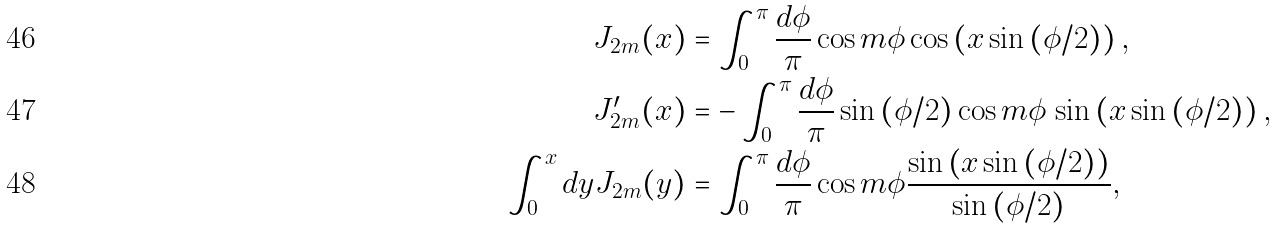<formula> <loc_0><loc_0><loc_500><loc_500>J _ { 2 m } ( x ) & = \int _ { 0 } ^ { \pi } \frac { d \phi } { \pi } \cos m \phi \cos \left ( x \sin \left ( \phi / 2 \right ) \right ) , \\ J _ { 2 m } ^ { \prime } ( x ) & = - \int _ { 0 } ^ { \pi } \frac { d \phi } { \pi } \sin \left ( \phi / 2 \right ) \cos m \phi \, \sin \left ( x \sin \left ( \phi / 2 \right ) \right ) , \\ \int _ { 0 } ^ { x } d y J _ { 2 m } ( y ) & = \int _ { 0 } ^ { \pi } \frac { d \phi } { \pi } \cos m \phi \frac { \sin \left ( x \sin \left ( \phi / 2 \right ) \right ) } { \sin \left ( \phi / 2 \right ) } ,</formula> 